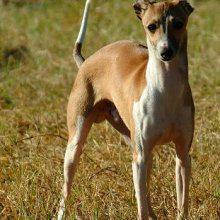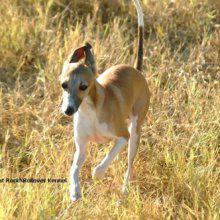The first image is the image on the left, the second image is the image on the right. Assess this claim about the two images: "All of the dogs are outside and none of them is wearing a collar.". Correct or not? Answer yes or no. Yes. The first image is the image on the left, the second image is the image on the right. For the images shown, is this caption "In one image, are two dogs facing towards the camera." true? Answer yes or no. No. 